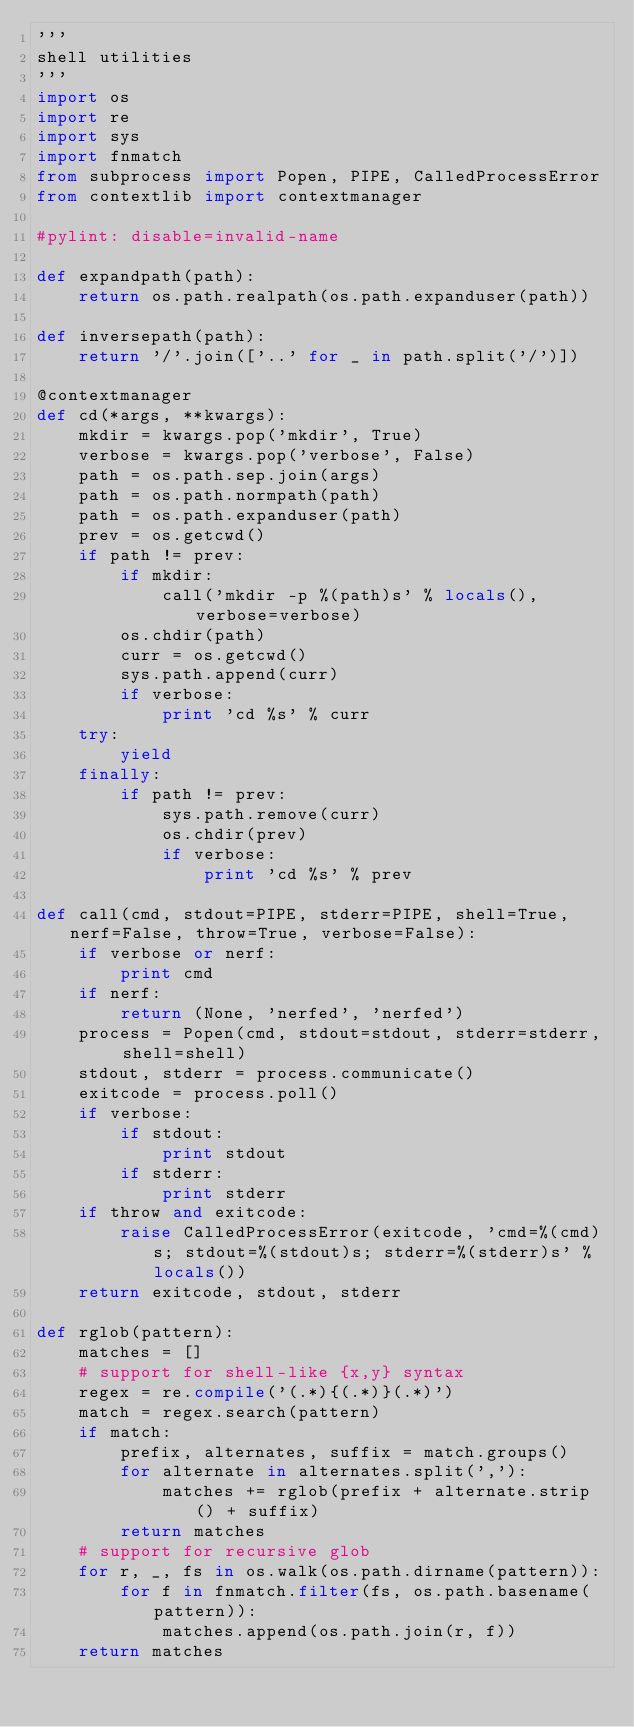Convert code to text. <code><loc_0><loc_0><loc_500><loc_500><_Python_>'''
shell utilities
'''
import os
import re
import sys
import fnmatch
from subprocess import Popen, PIPE, CalledProcessError
from contextlib import contextmanager

#pylint: disable=invalid-name

def expandpath(path):
    return os.path.realpath(os.path.expanduser(path))

def inversepath(path):
    return '/'.join(['..' for _ in path.split('/')])

@contextmanager
def cd(*args, **kwargs):
    mkdir = kwargs.pop('mkdir', True)
    verbose = kwargs.pop('verbose', False)
    path = os.path.sep.join(args)
    path = os.path.normpath(path)
    path = os.path.expanduser(path)
    prev = os.getcwd()
    if path != prev:
        if mkdir:
            call('mkdir -p %(path)s' % locals(), verbose=verbose)
        os.chdir(path)
        curr = os.getcwd()
        sys.path.append(curr)
        if verbose:
            print 'cd %s' % curr
    try:
        yield
    finally:
        if path != prev:
            sys.path.remove(curr)
            os.chdir(prev)
            if verbose:
                print 'cd %s' % prev

def call(cmd, stdout=PIPE, stderr=PIPE, shell=True, nerf=False, throw=True, verbose=False):
    if verbose or nerf:
        print cmd
    if nerf:
        return (None, 'nerfed', 'nerfed')
    process = Popen(cmd, stdout=stdout, stderr=stderr, shell=shell)
    stdout, stderr = process.communicate()
    exitcode = process.poll()
    if verbose:
        if stdout:
            print stdout
        if stderr:
            print stderr
    if throw and exitcode:
        raise CalledProcessError(exitcode, 'cmd=%(cmd)s; stdout=%(stdout)s; stderr=%(stderr)s' % locals())
    return exitcode, stdout, stderr

def rglob(pattern):
    matches = []
    # support for shell-like {x,y} syntax
    regex = re.compile('(.*){(.*)}(.*)')
    match = regex.search(pattern)
    if match:
        prefix, alternates, suffix = match.groups()
        for alternate in alternates.split(','):
            matches += rglob(prefix + alternate.strip() + suffix)
        return matches
    # support for recursive glob
    for r, _, fs in os.walk(os.path.dirname(pattern)):
        for f in fnmatch.filter(fs, os.path.basename(pattern)):
            matches.append(os.path.join(r, f))
    return matches

</code> 